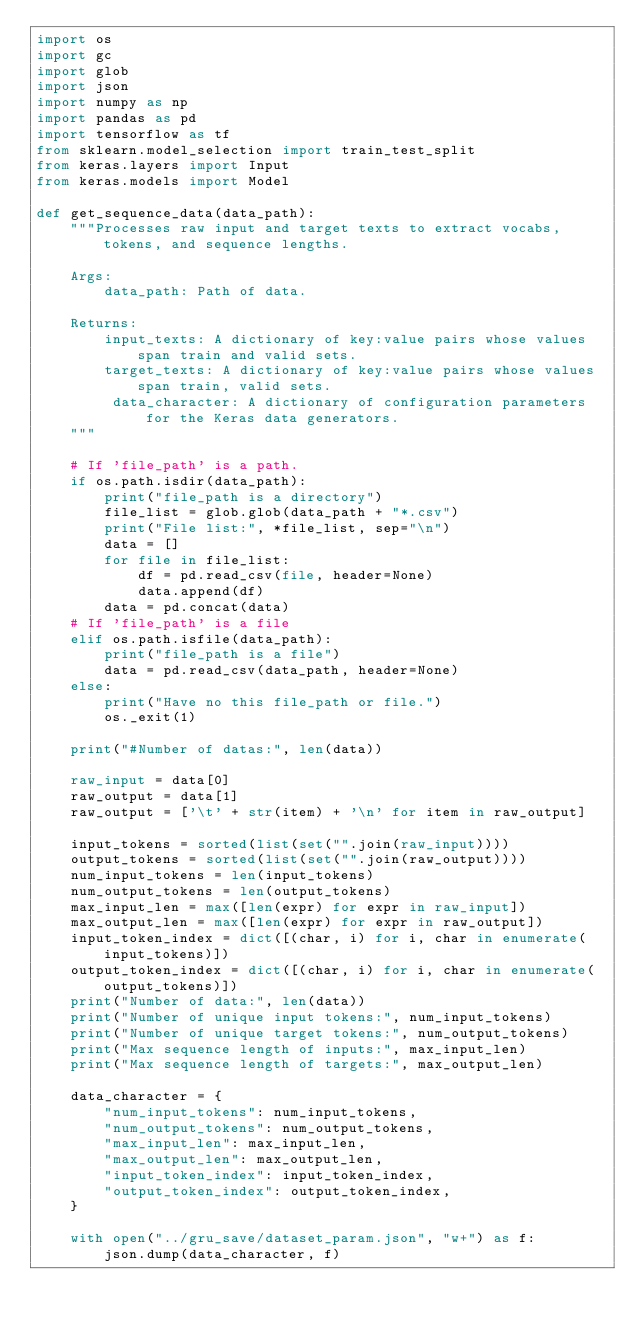<code> <loc_0><loc_0><loc_500><loc_500><_Python_>import os
import gc
import glob
import json
import numpy as np
import pandas as pd
import tensorflow as tf
from sklearn.model_selection import train_test_split
from keras.layers import Input
from keras.models import Model

def get_sequence_data(data_path):
    """Processes raw input and target texts to extract vocabs, tokens, and sequence lengths.

    Args:
        data_path: Path of data.

    Returns:
        input_texts: A dictionary of key:value pairs whose values span train and valid sets.
        target_texts: A dictionary of key:value pairs whose values span train, valid sets.
         data_character: A dictionary of configuration parameters for the Keras data generators.
    """

    # If 'file_path' is a path.
    if os.path.isdir(data_path):
        print("file_path is a directory")
        file_list = glob.glob(data_path + "*.csv")
        print("File list:", *file_list, sep="\n")
        data = []
        for file in file_list:
            df = pd.read_csv(file, header=None)
            data.append(df)
        data = pd.concat(data)
    # If 'file_path' is a file
    elif os.path.isfile(data_path):
        print("file_path is a file")
        data = pd.read_csv(data_path, header=None)
    else:
        print("Have no this file_path or file.")
        os._exit(1)

    print("#Number of datas:", len(data))
    
    raw_input = data[0]
    raw_output = data[1]
    raw_output = ['\t' + str(item) + '\n' for item in raw_output]

    input_tokens = sorted(list(set("".join(raw_input))))
    output_tokens = sorted(list(set("".join(raw_output))))
    num_input_tokens = len(input_tokens)
    num_output_tokens = len(output_tokens)
    max_input_len = max([len(expr) for expr in raw_input])
    max_output_len = max([len(expr) for expr in raw_output])
    input_token_index = dict([(char, i) for i, char in enumerate(input_tokens)])
    output_token_index = dict([(char, i) for i, char in enumerate(output_tokens)])
    print("Number of data:", len(data))
    print("Number of unique input tokens:", num_input_tokens)
    print("Number of unique target tokens:", num_output_tokens)
    print("Max sequence length of inputs:", max_input_len)
    print("Max sequence length of targets:", max_output_len)
   
    data_character = {
        "num_input_tokens": num_input_tokens,
        "num_output_tokens": num_output_tokens,
        "max_input_len": max_input_len,
        "max_output_len": max_output_len,
        "input_token_index": input_token_index,
        "output_token_index": output_token_index,
    }

    with open("../gru_save/dataset_param.json", "w+") as f:
        json.dump(data_character, f)
</code> 